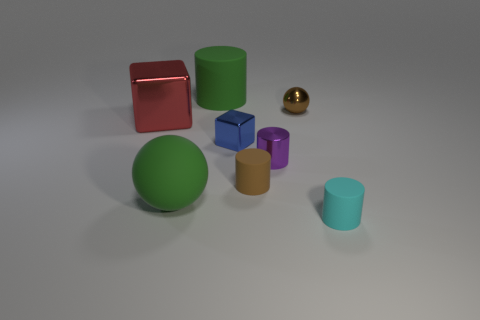Subtract 1 cylinders. How many cylinders are left? 3 Subtract all tiny purple cylinders. How many cylinders are left? 3 Subtract all brown cylinders. How many cylinders are left? 3 Add 1 tiny cyan metallic things. How many objects exist? 9 Subtract all blue cylinders. Subtract all blue spheres. How many cylinders are left? 4 Subtract all spheres. How many objects are left? 6 Add 6 big balls. How many big balls exist? 7 Subtract 0 yellow cylinders. How many objects are left? 8 Subtract all tiny rubber things. Subtract all metallic things. How many objects are left? 2 Add 2 cylinders. How many cylinders are left? 6 